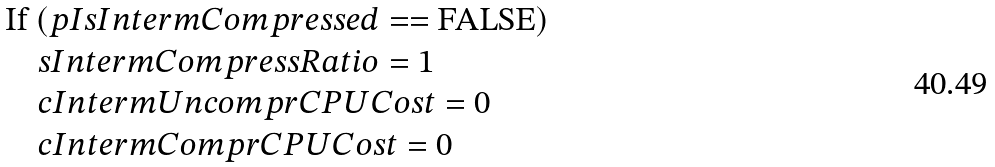<formula> <loc_0><loc_0><loc_500><loc_500>& \text {If } ( p I s I n t e r m C o m p r e s s e d = = \text {FALSE} ) \\ & \quad s I n t e r m C o m p r e s s R a t i o = 1 \\ & \quad c I n t e r m U n c o m p r C P U C o s t = 0 \\ & \quad c I n t e r m C o m p r C P U C o s t = 0</formula> 